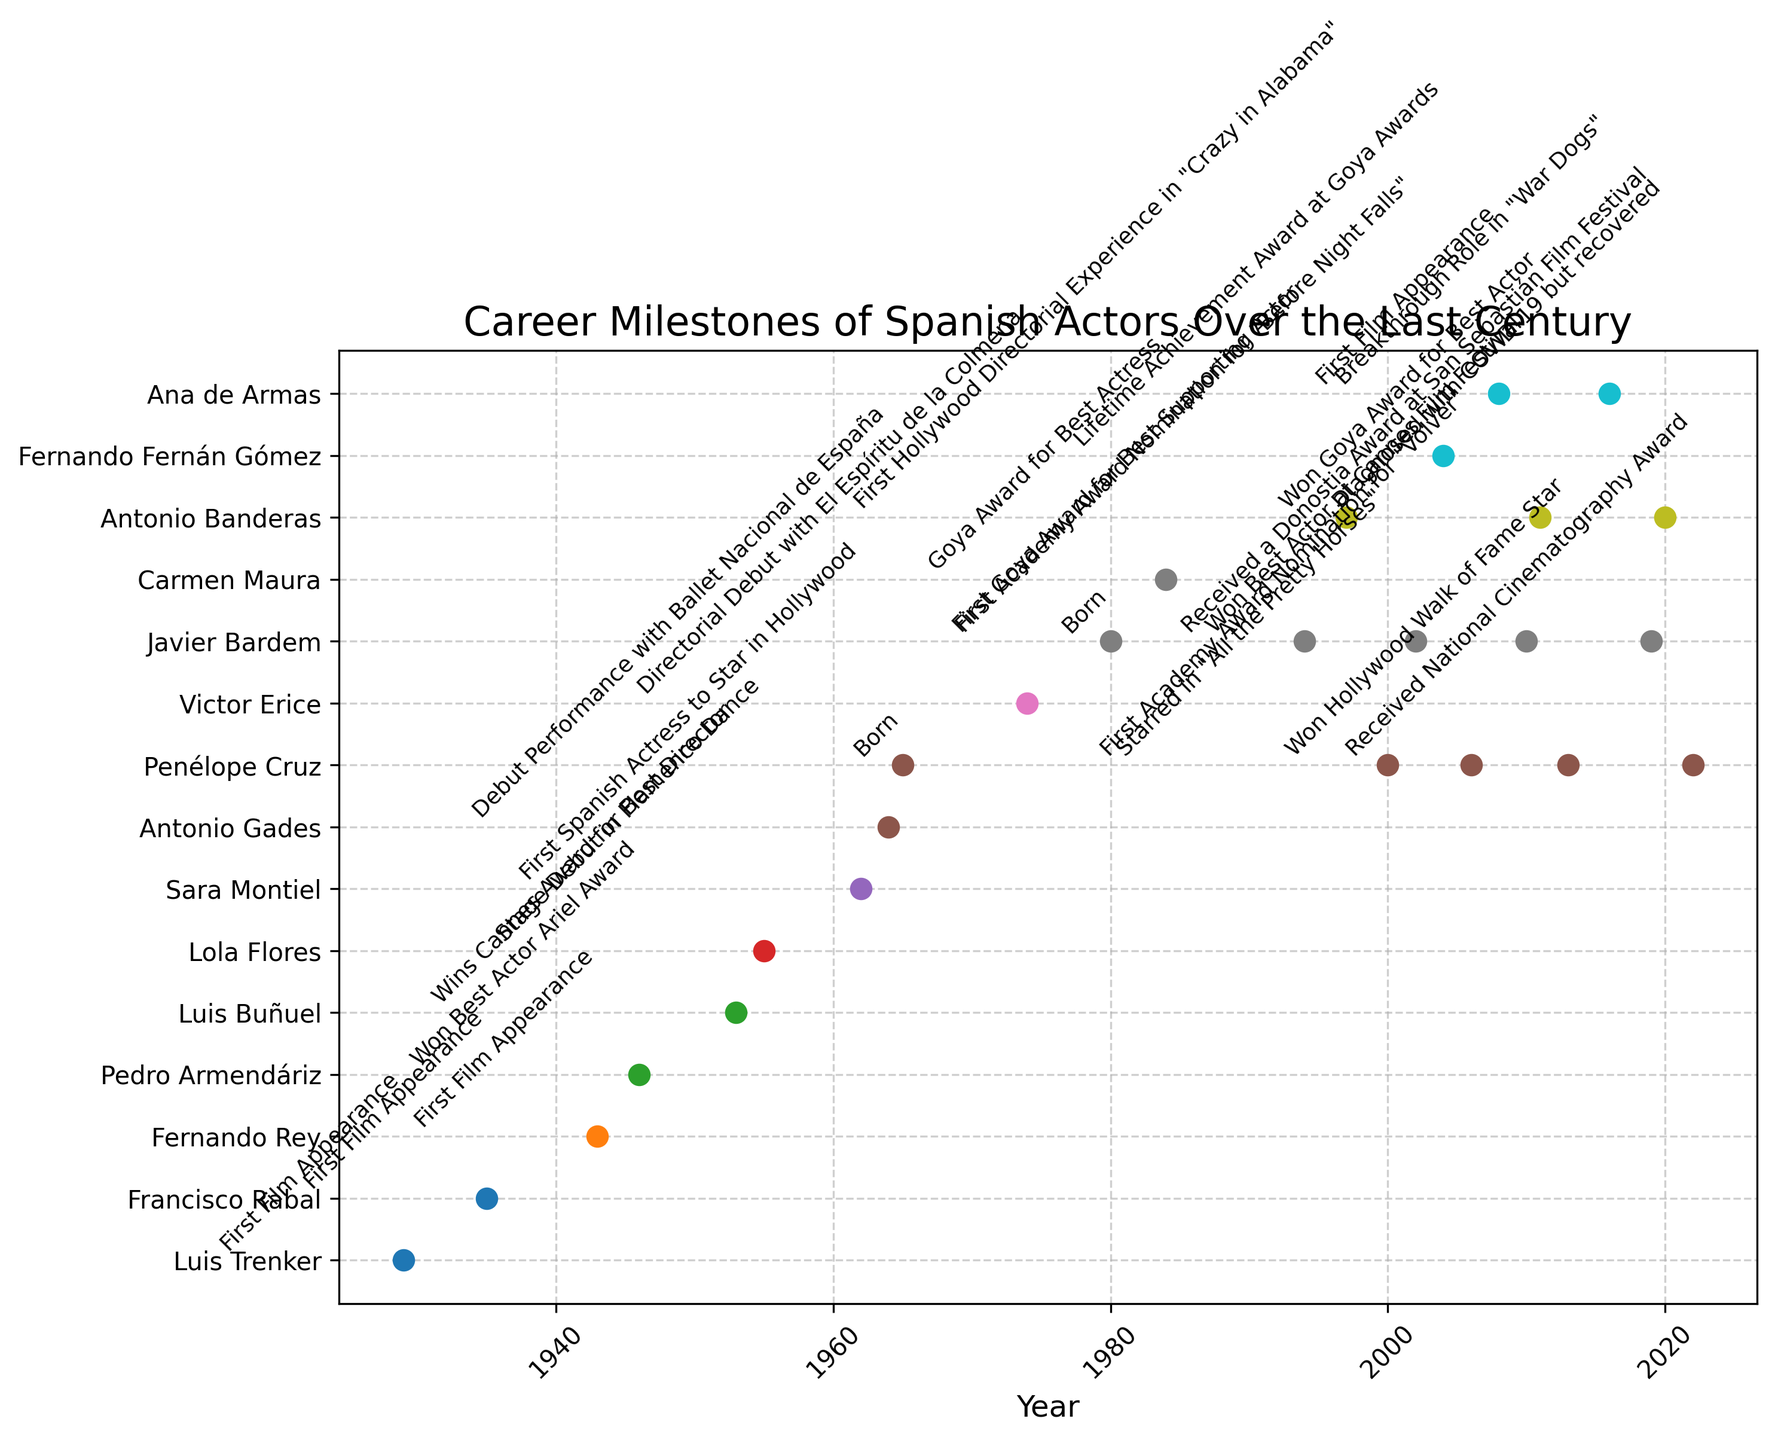What's the earliest milestone mentioned in the plot? The earliest milestone can be identified by looking for the data point on the far left of the x-axis (earliest year). Here we see that Luis Trenker's first film appearance in 1929 is the earliest marker.
Answer: 1929 Which actor has the most milestones shown in the figure? Counting the individual milestone markers and labels per actor, Javier Bardem has the most milestones with a total of five significant events.
Answer: Javier Bardem How many actors received an Academy Award nomination, and in which years did they occur? Dropping milestones related to Academy Award nominations shows Javier Bardem was nominated in 2002 and Penélope Cruz was nominated in 2006. This makes a total of two actors.
Answer: 2; 2002, 2006 Who was born first, Penélope Cruz or Javier Bardem? By examining the birth years, Penélope Cruz was born in 1965 and Javier Bardem was born in 1980. Thus, Penélope Cruz was born first.
Answer: Penélope Cruz What is the average time between milestones for Javier Bardem? Identify the years Javier Bardem’s milestones occurred (1980, 1994, 2002, 2010, 2019) and find the intervals between them: 14, 8, 8, and 9 years. Then calculate the average of these intervals: (14 + 8 + 8 + 9) / 4 = 39 / 4 = 9.75 years.
Answer: 9.75 years Which actor made their first appearance in Hollywood, and in what year? Checking milestones related to the first Hollywood appearance, we see that Sara Montiel was the first Spanish actress to star in Hollywood in 1962.
Answer: Sara Montiel, 1962 How many awards did Antonio Banderas receive according to the plot? Examining the milestones, Antonio Banderas received three awards in the given data: first Hollywood directorial experience in 1997, a Goya Award in 2011, and noted for his recovery from COVID-19 in 2020.
Answer: 3 Compare the milestones of Penélope Cruz and Ana de Armas. Who had more milestones mentioned within the plot? Penélope Cruz has four milestones (born in 1965, starred in “All the Pretty Horses” in 2000, first Academy Award nomination in 2006, and Hollywood Walk of Fame star in 2013) while Ana de Armas has two milestones (first film appearance in 2008 and breakthrough role in “War Dogs” in 2016).
Answer: Penélope Cruz What is the difference in years between Luis Buñuel winning the Cannes Award for Best Director and Antonio Gades’ debut performance? Luis Buñuel’s Cannes award is in 1953, and Antonio Gades’ debut performance is in 1964. The difference in years is 1964 - 1953 = 11 years.
Answer: 11 years 